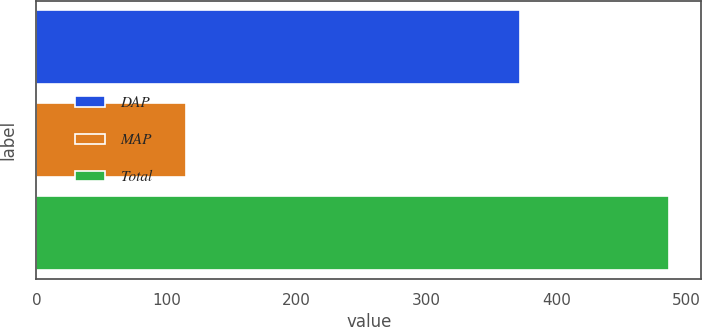Convert chart to OTSL. <chart><loc_0><loc_0><loc_500><loc_500><bar_chart><fcel>DAP<fcel>MAP<fcel>Total<nl><fcel>372<fcel>115<fcel>487<nl></chart> 